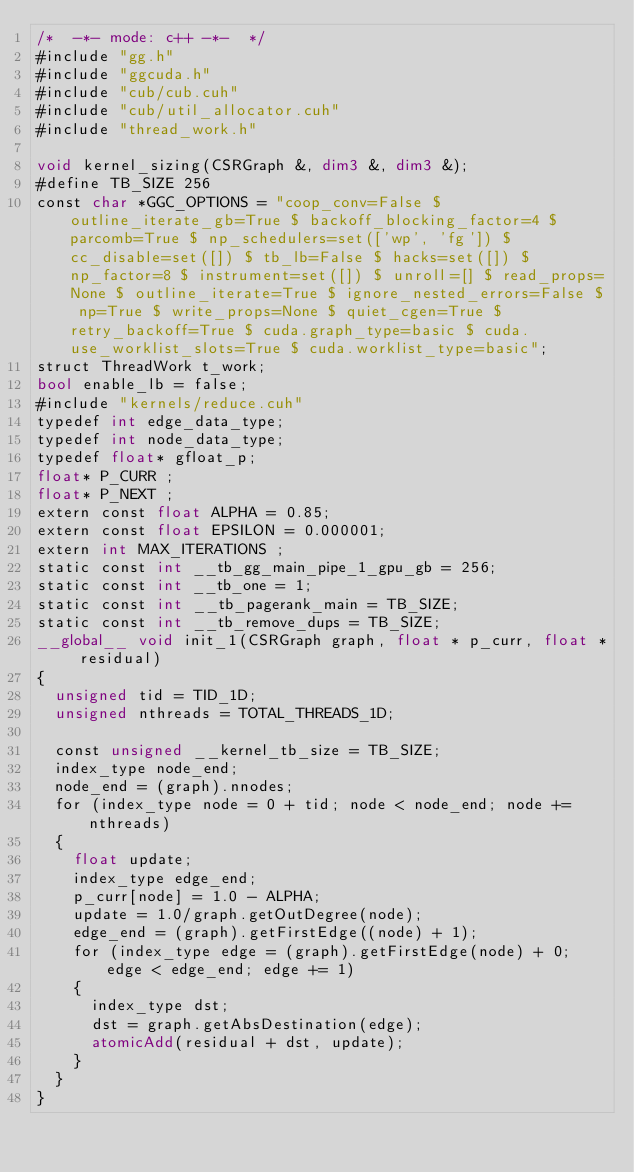Convert code to text. <code><loc_0><loc_0><loc_500><loc_500><_Cuda_>/*  -*- mode: c++ -*-  */
#include "gg.h"
#include "ggcuda.h"
#include "cub/cub.cuh"
#include "cub/util_allocator.cuh"
#include "thread_work.h"

void kernel_sizing(CSRGraph &, dim3 &, dim3 &);
#define TB_SIZE 256
const char *GGC_OPTIONS = "coop_conv=False $ outline_iterate_gb=True $ backoff_blocking_factor=4 $ parcomb=True $ np_schedulers=set(['wp', 'fg']) $ cc_disable=set([]) $ tb_lb=False $ hacks=set([]) $ np_factor=8 $ instrument=set([]) $ unroll=[] $ read_props=None $ outline_iterate=True $ ignore_nested_errors=False $ np=True $ write_props=None $ quiet_cgen=True $ retry_backoff=True $ cuda.graph_type=basic $ cuda.use_worklist_slots=True $ cuda.worklist_type=basic";
struct ThreadWork t_work;
bool enable_lb = false;
#include "kernels/reduce.cuh"
typedef int edge_data_type;
typedef int node_data_type;
typedef float* gfloat_p;
float* P_CURR ;
float* P_NEXT ;
extern const float ALPHA = 0.85;
extern const float EPSILON = 0.000001;
extern int MAX_ITERATIONS ;
static const int __tb_gg_main_pipe_1_gpu_gb = 256;
static const int __tb_one = 1;
static const int __tb_pagerank_main = TB_SIZE;
static const int __tb_remove_dups = TB_SIZE;
__global__ void init_1(CSRGraph graph, float * p_curr, float * residual)
{
  unsigned tid = TID_1D;
  unsigned nthreads = TOTAL_THREADS_1D;

  const unsigned __kernel_tb_size = TB_SIZE;
  index_type node_end;
  node_end = (graph).nnodes;
  for (index_type node = 0 + tid; node < node_end; node += nthreads)
  {
    float update;
    index_type edge_end;
    p_curr[node] = 1.0 - ALPHA;
    update = 1.0/graph.getOutDegree(node);
    edge_end = (graph).getFirstEdge((node) + 1);
    for (index_type edge = (graph).getFirstEdge(node) + 0; edge < edge_end; edge += 1)
    {
      index_type dst;
      dst = graph.getAbsDestination(edge);
      atomicAdd(residual + dst, update);
    }
  }
}</code> 